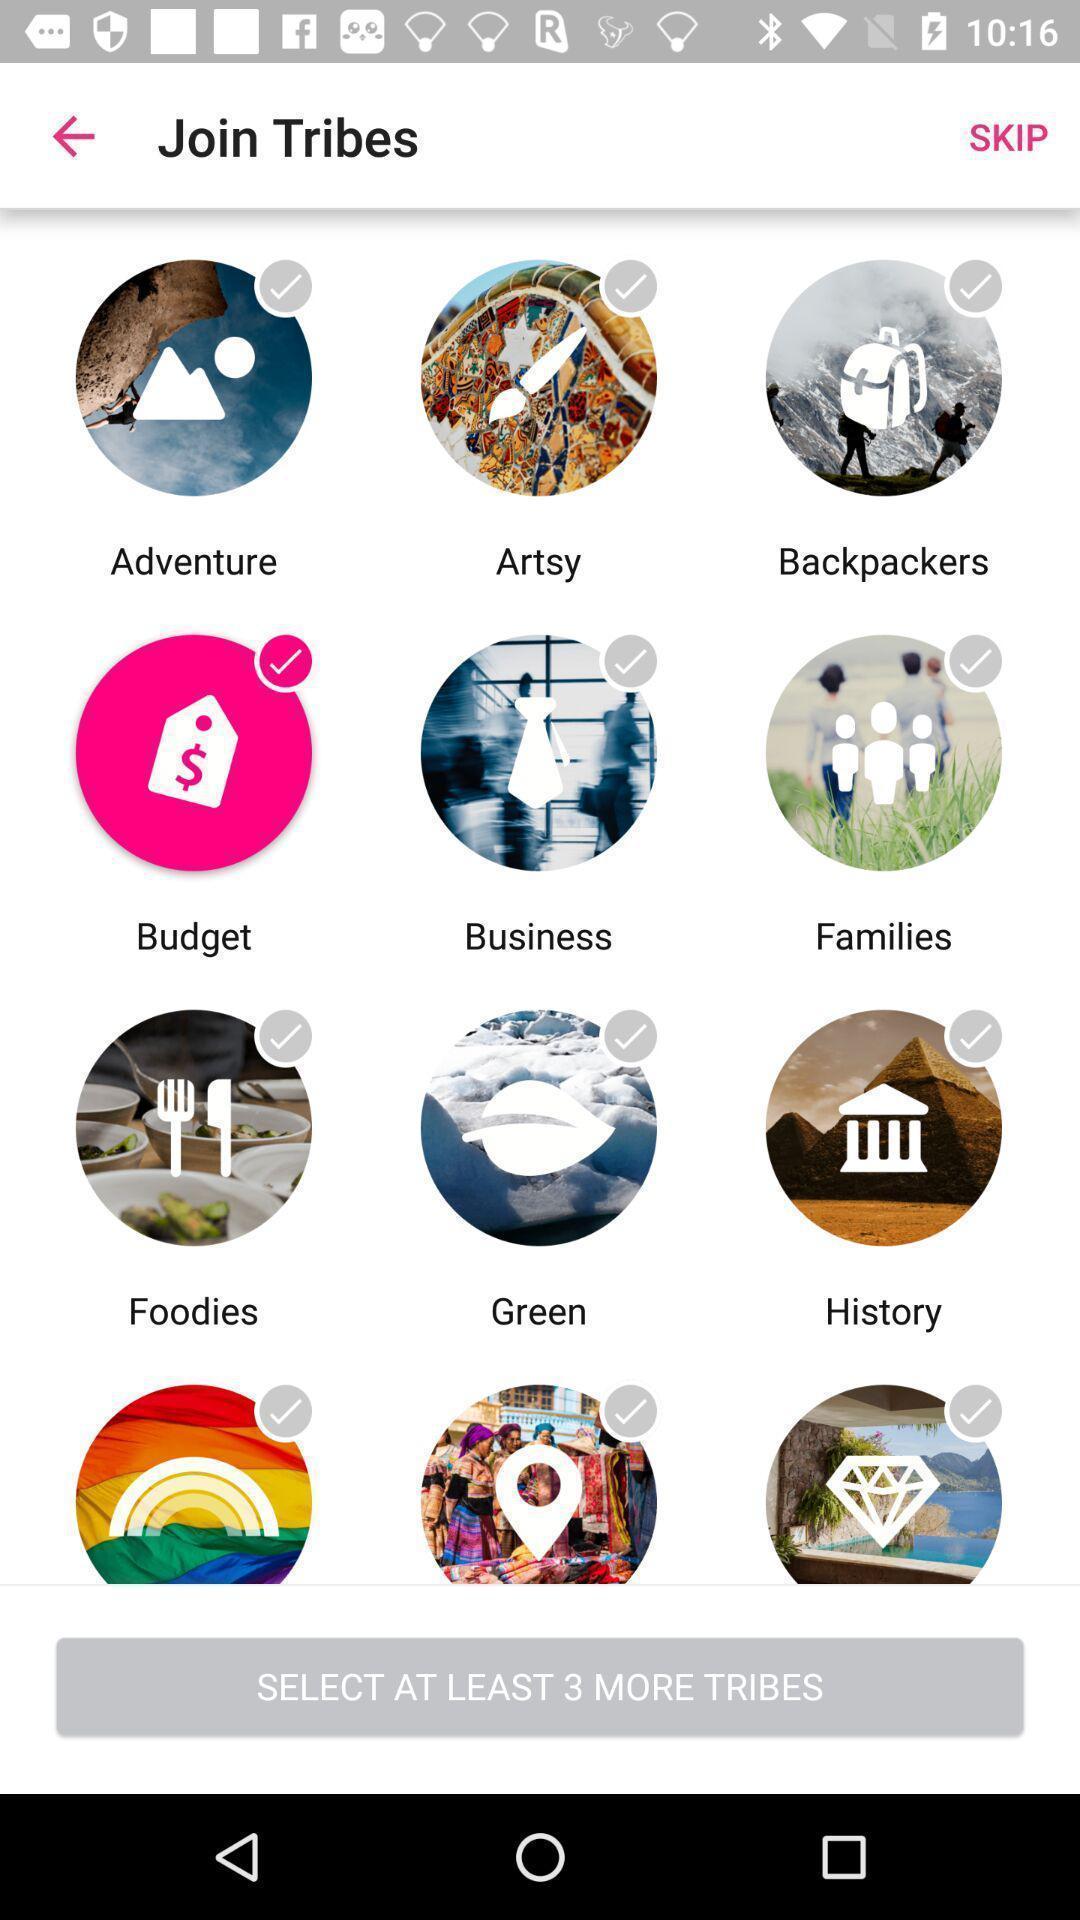What details can you identify in this image? Screen shows multiple select options. 